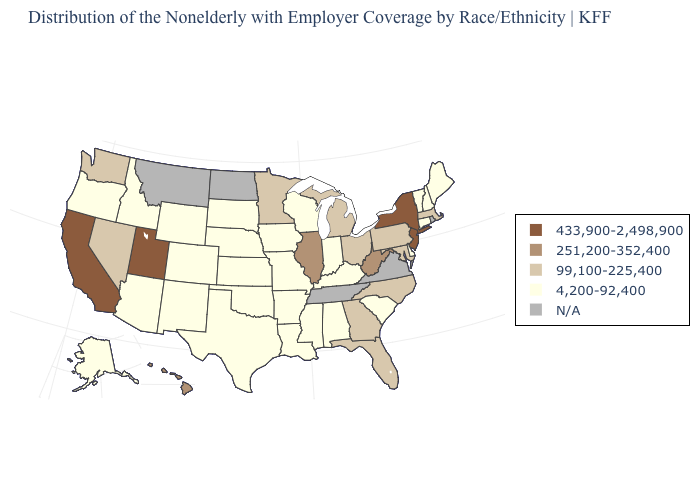Among the states that border Connecticut , which have the highest value?
Give a very brief answer. New York. How many symbols are there in the legend?
Concise answer only. 5. What is the value of Maine?
Concise answer only. 4,200-92,400. Does New Jersey have the lowest value in the Northeast?
Write a very short answer. No. What is the lowest value in states that border Texas?
Be succinct. 4,200-92,400. What is the highest value in states that border New York?
Keep it brief. 433,900-2,498,900. Does the first symbol in the legend represent the smallest category?
Keep it brief. No. Does the first symbol in the legend represent the smallest category?
Answer briefly. No. Among the states that border Virginia , does North Carolina have the highest value?
Answer briefly. No. What is the value of Vermont?
Concise answer only. 4,200-92,400. Name the states that have a value in the range 433,900-2,498,900?
Keep it brief. California, New Jersey, New York, Utah. How many symbols are there in the legend?
Write a very short answer. 5. 